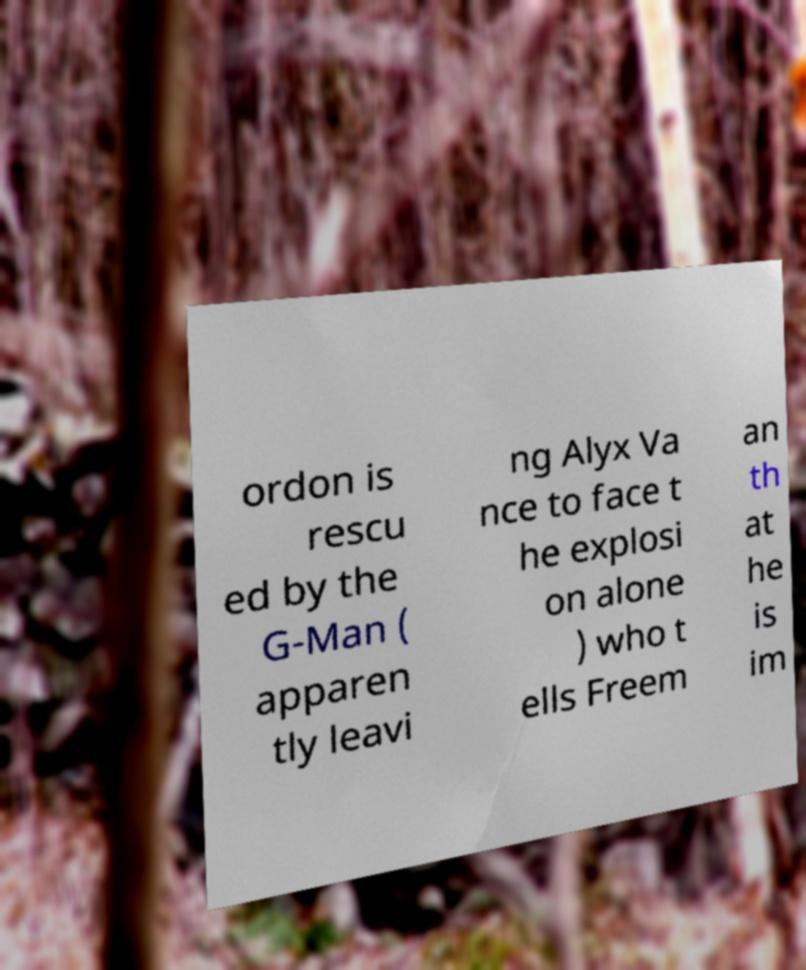Please read and relay the text visible in this image. What does it say? ordon is rescu ed by the G-Man ( apparen tly leavi ng Alyx Va nce to face t he explosi on alone ) who t ells Freem an th at he is im 